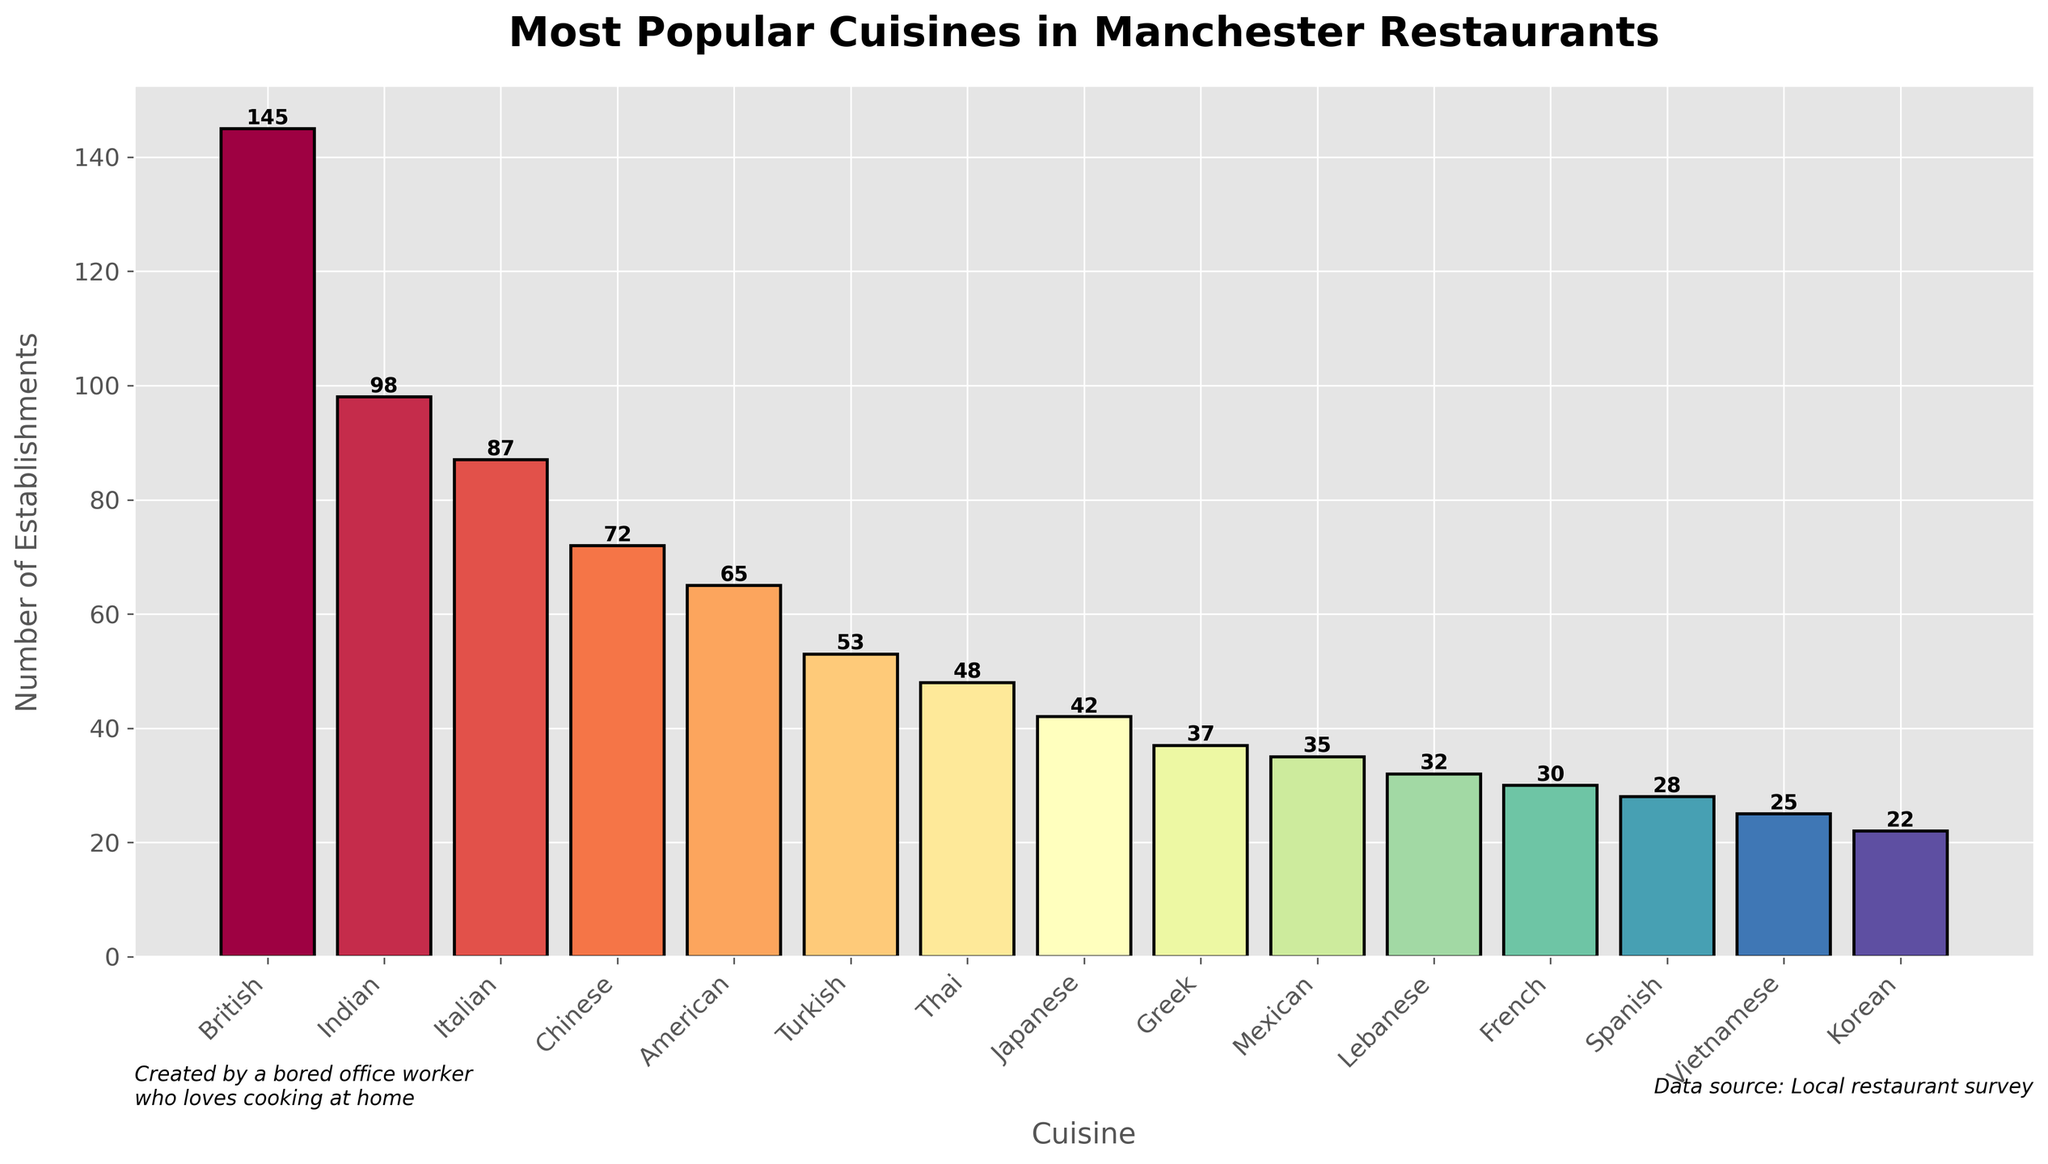Which cuisine has the highest number of establishments? To find out which cuisine has the highest number of establishments, look for the tallest bar in the chart. The British cuisine has the tallest bar with 145 establishments.
Answer: British, 145 Which cuisine has fewer establishments than Turkish but more than Greek? Identify the number of establishments for Turkish (53) and Greek (37). Thai cuisine, with 48 establishments, falls between these two values.
Answer: Thai, 48 How many more establishments are there for Indian cuisine compared to Mexican? Locate the number of establishments for Indian cuisine (98) and Mexican (35). Subtract the lower value from the higher value: 98 - 35 = 63.
Answer: 63 What is the combined total of American, Turkish, and Thai establishments? Sum the number of establishments for American (65), Turkish (53), and Thai (48): 65 + 53 + 48 = 166.
Answer: 166 Which cuisine is represented by the shortest bar? Find the shortest bar in the chart, which corresponds to the cuisine with the fewest establishments. Korean cuisine, with 22 establishments, is the shortest.
Answer: Korean, 22 How many establishments do the top three cuisines account for in total? Identify the top three cuisines (British, Indian, Italian) and their respective number of establishments (145, 98, 87). Sum them up: 145 + 98 + 87 = 330.
Answer: 330 Is the number of Chinese establishments more than half the number of British establishments? Determine the number of establishments for British cuisine (145) and half of that number (145 / 2 = 72.5). The number of Chinese establishments (72) is slightly less than this value.
Answer: No By how much do the American establishments outnumber the Japanese establishments? Locate the number of establishments for American (65) and Japanese (42). Subtract the number of Japanese establishments from the American ones: 65 - 42 = 23.
Answer: 23 If you combine Greek and Lebanese establishments, do they surpass Italian establishments? Add the number of establishments for Greek (37) and Lebanese (32): 37 + 32 = 69. Compare this to Italian establishments (87); 69 is less than 87.
Answer: No Which cuisines have between 40 and 50 establishments? Identify cuisines with establishments in the range of 40 to 50: Japanese (42) and Thai (48) fall within this range.
Answer: Japanese, 42 and Thai, 48 